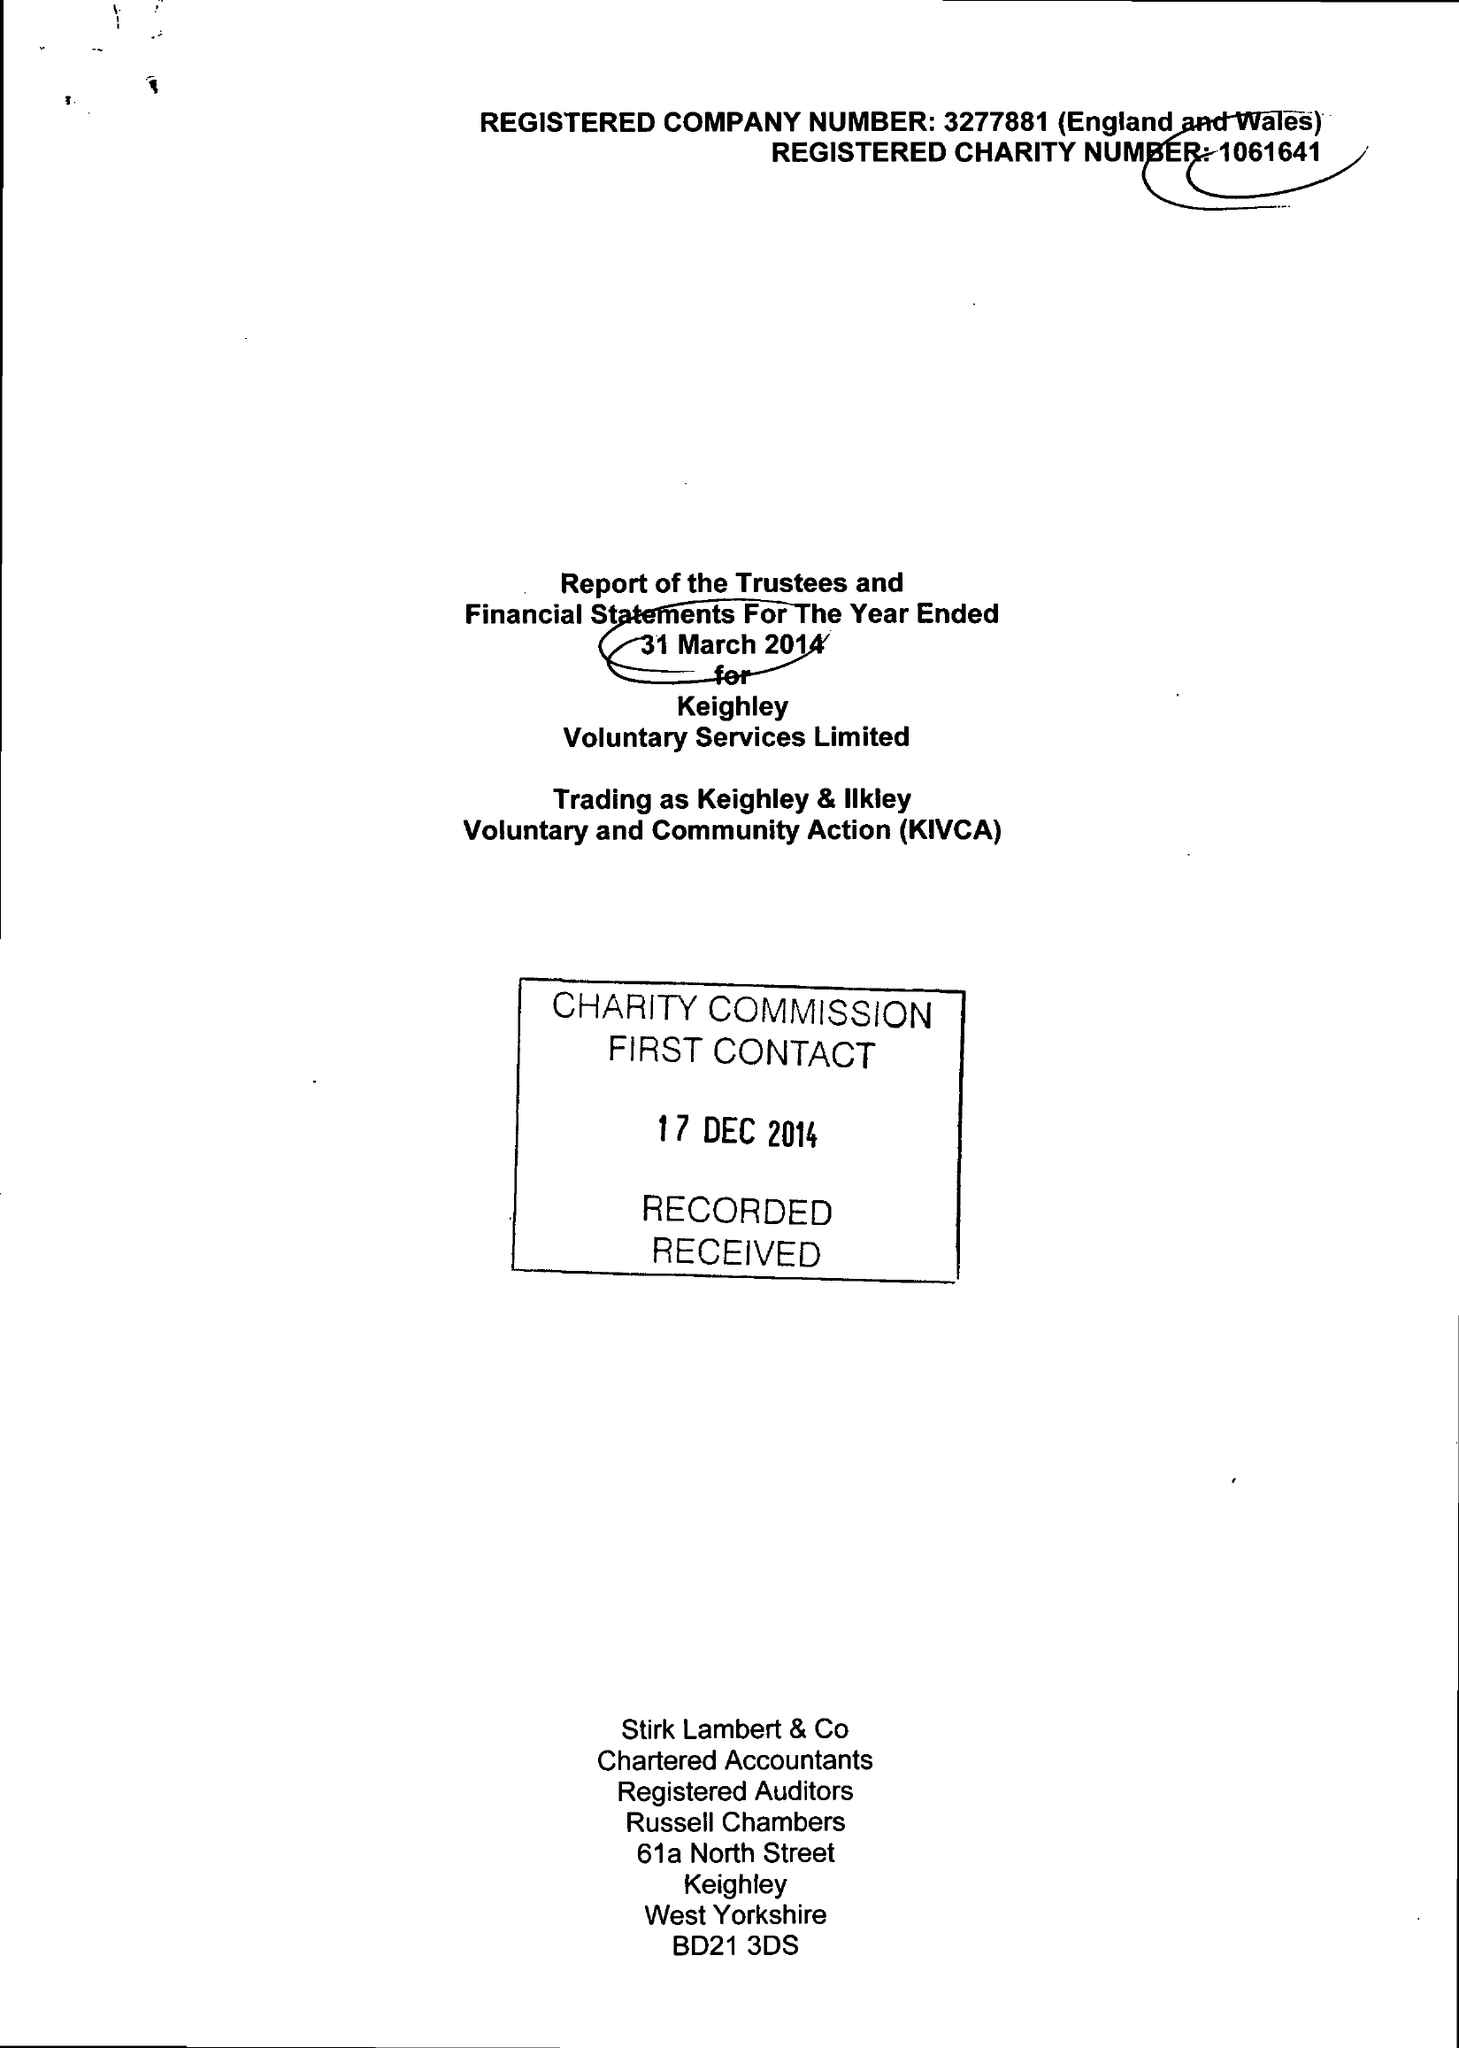What is the value for the charity_number?
Answer the question using a single word or phrase. 1061641 